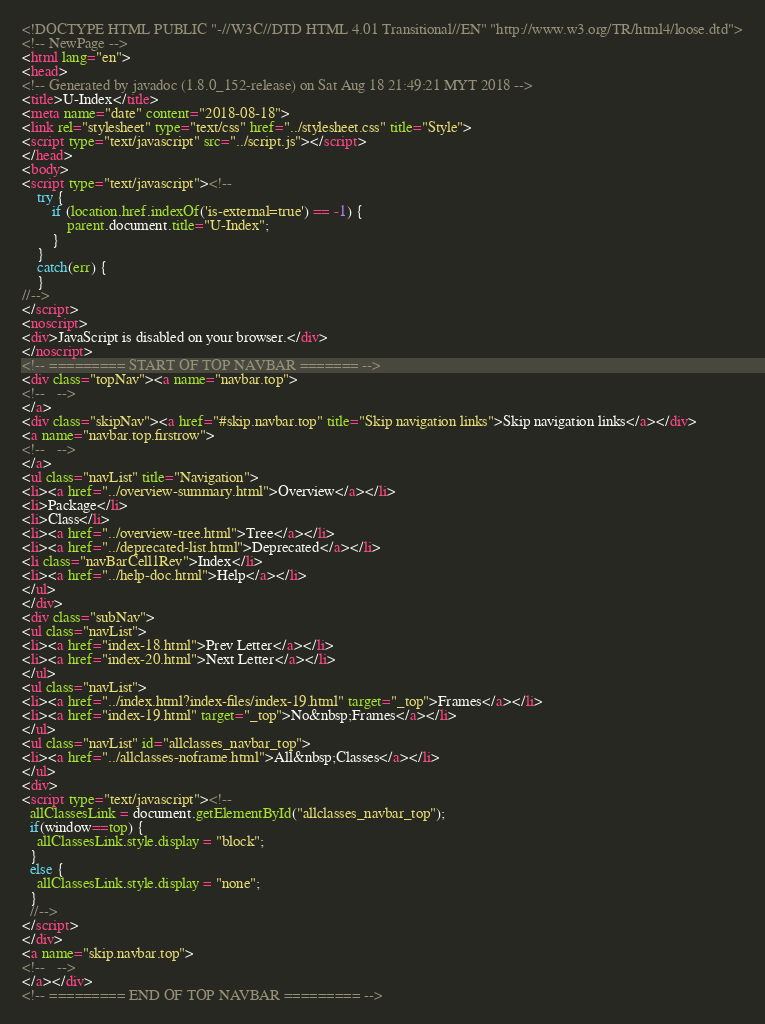Convert code to text. <code><loc_0><loc_0><loc_500><loc_500><_HTML_><!DOCTYPE HTML PUBLIC "-//W3C//DTD HTML 4.01 Transitional//EN" "http://www.w3.org/TR/html4/loose.dtd">
<!-- NewPage -->
<html lang="en">
<head>
<!-- Generated by javadoc (1.8.0_152-release) on Sat Aug 18 21:49:21 MYT 2018 -->
<title>U-Index</title>
<meta name="date" content="2018-08-18">
<link rel="stylesheet" type="text/css" href="../stylesheet.css" title="Style">
<script type="text/javascript" src="../script.js"></script>
</head>
<body>
<script type="text/javascript"><!--
    try {
        if (location.href.indexOf('is-external=true') == -1) {
            parent.document.title="U-Index";
        }
    }
    catch(err) {
    }
//-->
</script>
<noscript>
<div>JavaScript is disabled on your browser.</div>
</noscript>
<!-- ========= START OF TOP NAVBAR ======= -->
<div class="topNav"><a name="navbar.top">
<!--   -->
</a>
<div class="skipNav"><a href="#skip.navbar.top" title="Skip navigation links">Skip navigation links</a></div>
<a name="navbar.top.firstrow">
<!--   -->
</a>
<ul class="navList" title="Navigation">
<li><a href="../overview-summary.html">Overview</a></li>
<li>Package</li>
<li>Class</li>
<li><a href="../overview-tree.html">Tree</a></li>
<li><a href="../deprecated-list.html">Deprecated</a></li>
<li class="navBarCell1Rev">Index</li>
<li><a href="../help-doc.html">Help</a></li>
</ul>
</div>
<div class="subNav">
<ul class="navList">
<li><a href="index-18.html">Prev Letter</a></li>
<li><a href="index-20.html">Next Letter</a></li>
</ul>
<ul class="navList">
<li><a href="../index.html?index-files/index-19.html" target="_top">Frames</a></li>
<li><a href="index-19.html" target="_top">No&nbsp;Frames</a></li>
</ul>
<ul class="navList" id="allclasses_navbar_top">
<li><a href="../allclasses-noframe.html">All&nbsp;Classes</a></li>
</ul>
<div>
<script type="text/javascript"><!--
  allClassesLink = document.getElementById("allclasses_navbar_top");
  if(window==top) {
    allClassesLink.style.display = "block";
  }
  else {
    allClassesLink.style.display = "none";
  }
  //-->
</script>
</div>
<a name="skip.navbar.top">
<!--   -->
</a></div>
<!-- ========= END OF TOP NAVBAR ========= --></code> 